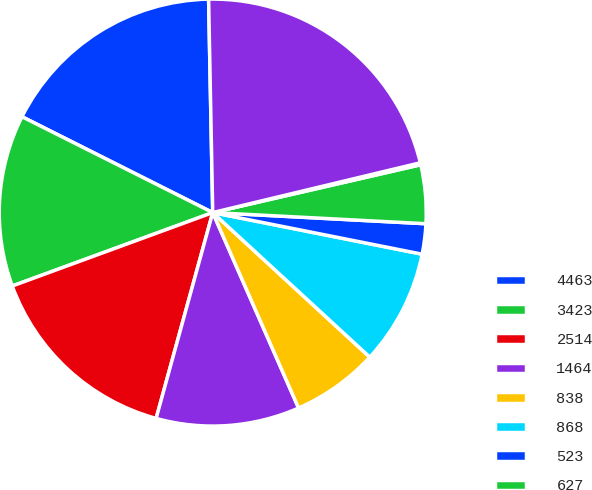<chart> <loc_0><loc_0><loc_500><loc_500><pie_chart><fcel>4463<fcel>3423<fcel>2514<fcel>1464<fcel>838<fcel>868<fcel>523<fcel>627<fcel>416<fcel>15136<nl><fcel>17.28%<fcel>13.0%<fcel>15.14%<fcel>10.86%<fcel>6.57%<fcel>8.72%<fcel>2.29%<fcel>4.43%<fcel>0.15%<fcel>21.56%<nl></chart> 